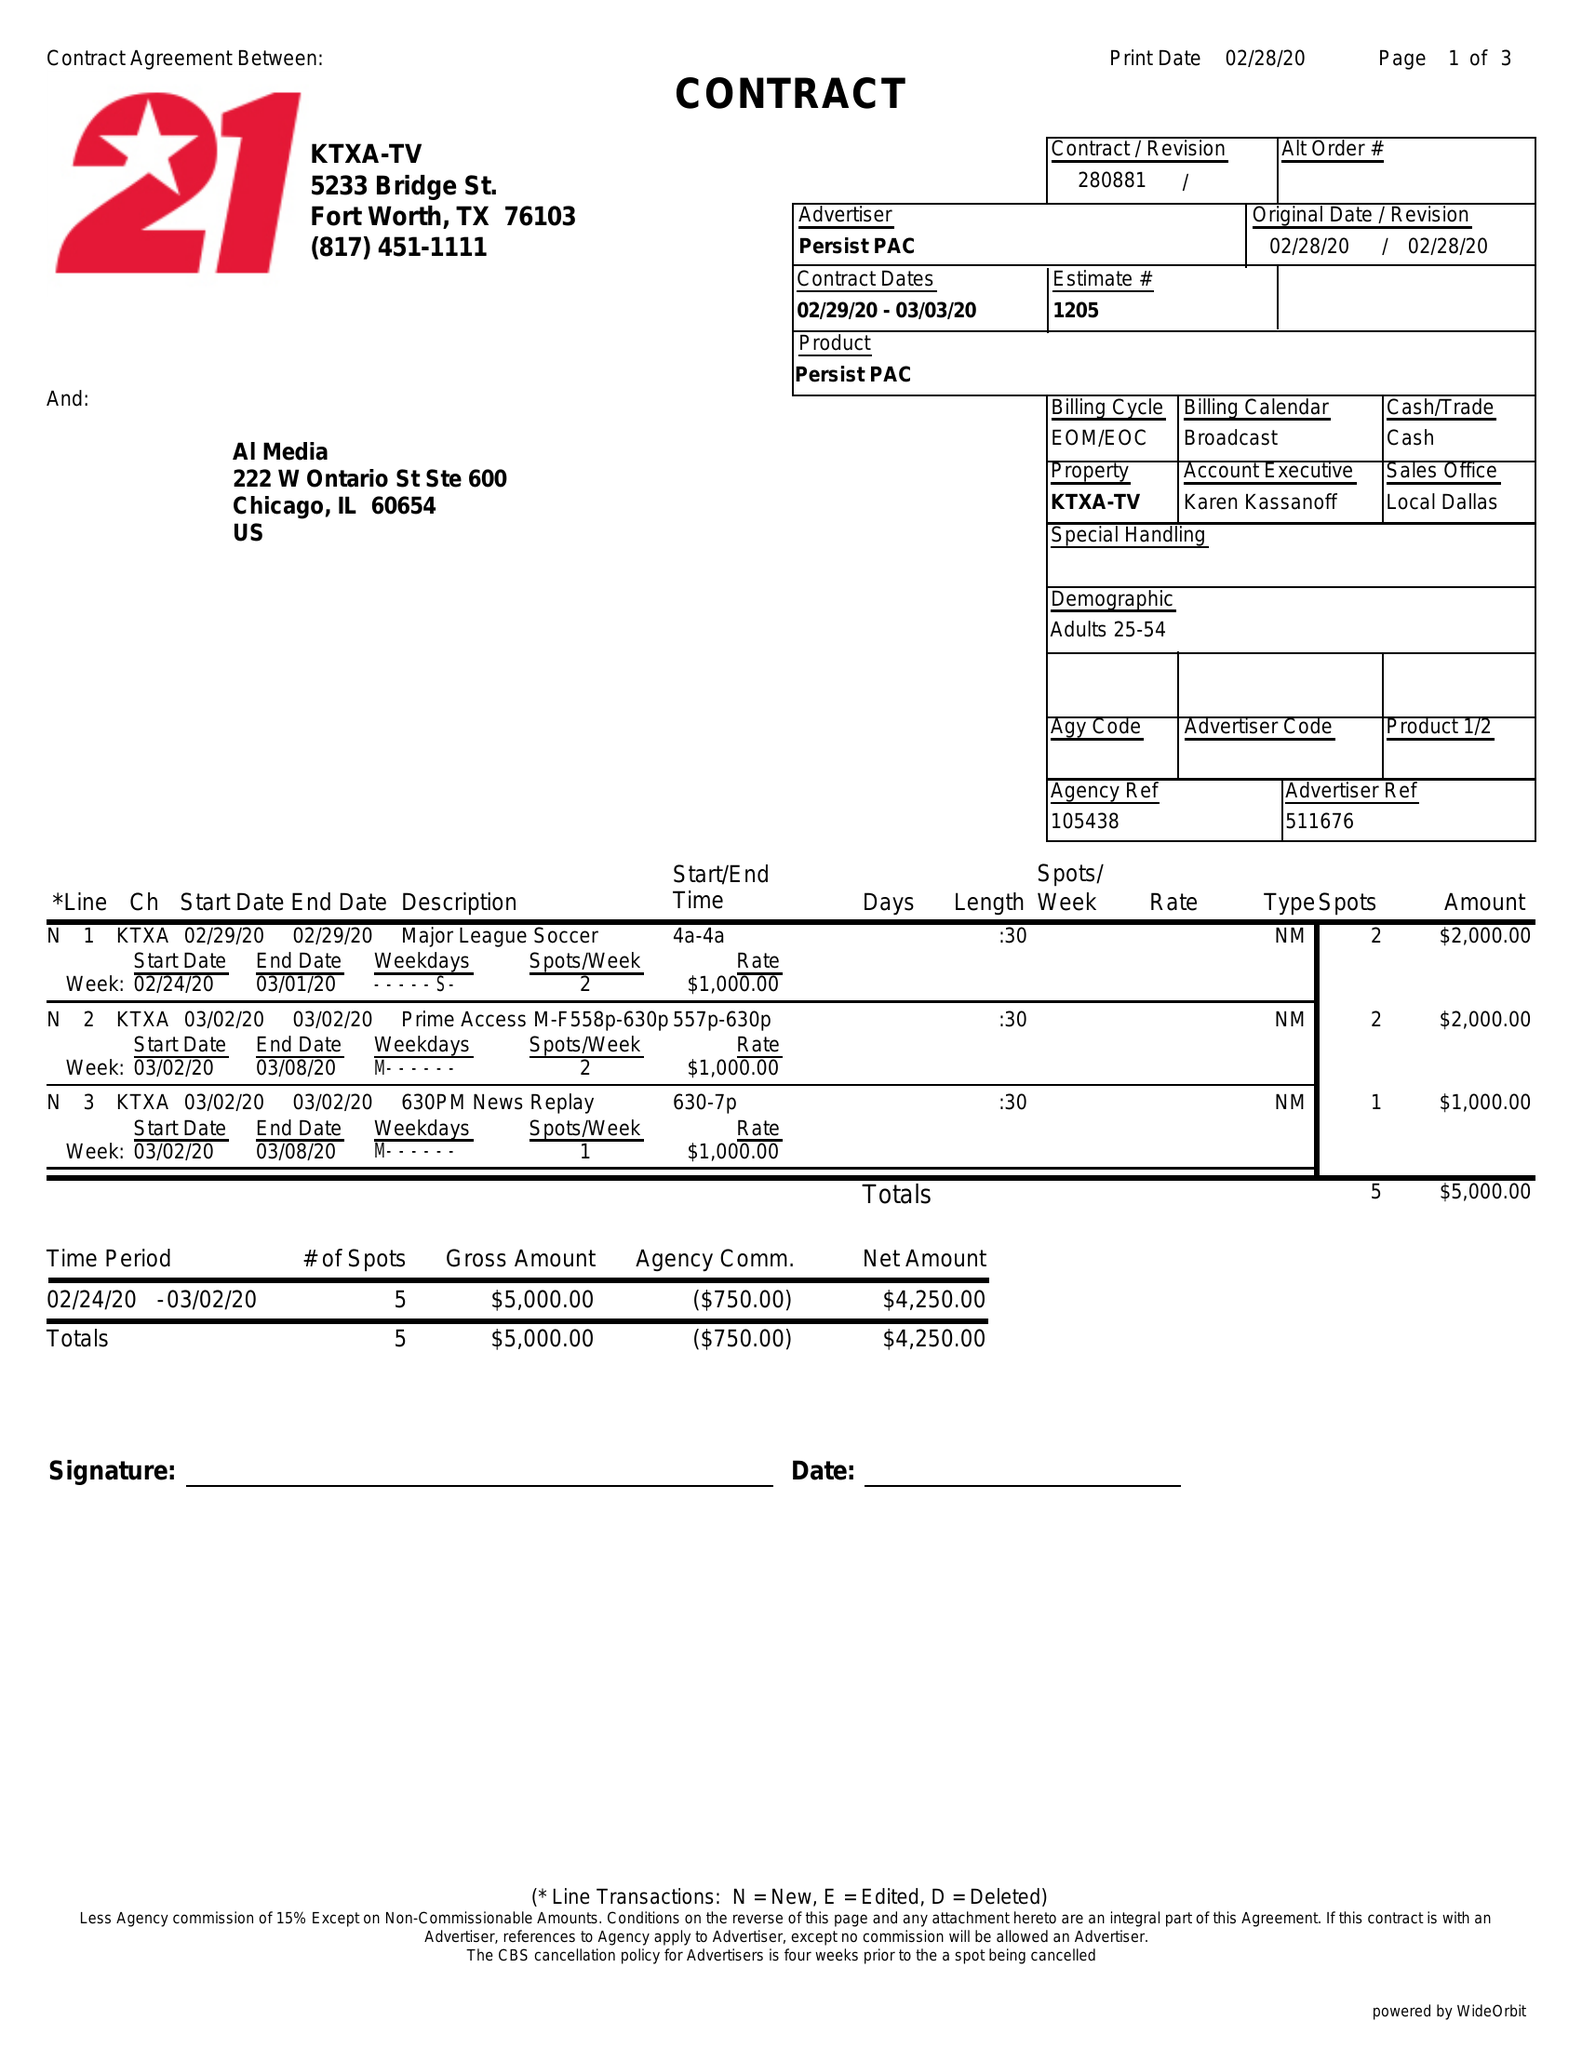What is the value for the gross_amount?
Answer the question using a single word or phrase. 5000.00 